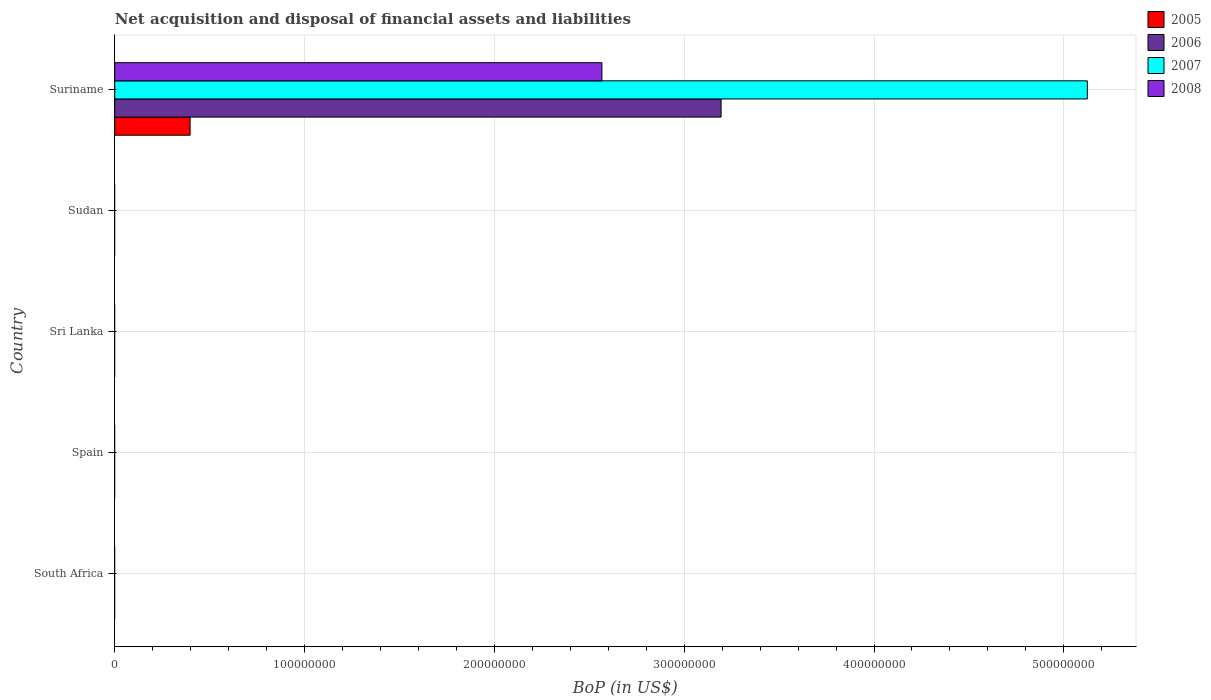How many different coloured bars are there?
Your answer should be compact. 4. How many bars are there on the 2nd tick from the top?
Offer a very short reply. 0. What is the label of the 2nd group of bars from the top?
Provide a short and direct response. Sudan. What is the Balance of Payments in 2006 in South Africa?
Offer a terse response. 0. Across all countries, what is the maximum Balance of Payments in 2006?
Give a very brief answer. 3.19e+08. Across all countries, what is the minimum Balance of Payments in 2005?
Ensure brevity in your answer.  0. In which country was the Balance of Payments in 2008 maximum?
Give a very brief answer. Suriname. What is the total Balance of Payments in 2005 in the graph?
Your response must be concise. 3.97e+07. What is the difference between the Balance of Payments in 2007 in Suriname and the Balance of Payments in 2005 in Spain?
Your answer should be compact. 5.12e+08. What is the average Balance of Payments in 2006 per country?
Ensure brevity in your answer.  6.39e+07. What is the difference between the Balance of Payments in 2005 and Balance of Payments in 2008 in Suriname?
Your answer should be very brief. -2.17e+08. What is the difference between the highest and the lowest Balance of Payments in 2005?
Your response must be concise. 3.97e+07. Is it the case that in every country, the sum of the Balance of Payments in 2005 and Balance of Payments in 2008 is greater than the Balance of Payments in 2007?
Your answer should be compact. No. How many bars are there?
Offer a very short reply. 4. Are the values on the major ticks of X-axis written in scientific E-notation?
Your response must be concise. No. Does the graph contain any zero values?
Make the answer very short. Yes. Does the graph contain grids?
Ensure brevity in your answer.  Yes. Where does the legend appear in the graph?
Provide a succinct answer. Top right. How many legend labels are there?
Offer a terse response. 4. How are the legend labels stacked?
Your response must be concise. Vertical. What is the title of the graph?
Keep it short and to the point. Net acquisition and disposal of financial assets and liabilities. Does "1970" appear as one of the legend labels in the graph?
Make the answer very short. No. What is the label or title of the X-axis?
Offer a very short reply. BoP (in US$). What is the label or title of the Y-axis?
Provide a succinct answer. Country. What is the BoP (in US$) in 2005 in South Africa?
Your answer should be compact. 0. What is the BoP (in US$) of 2006 in South Africa?
Give a very brief answer. 0. What is the BoP (in US$) of 2007 in South Africa?
Your answer should be very brief. 0. What is the BoP (in US$) of 2008 in South Africa?
Keep it short and to the point. 0. What is the BoP (in US$) in 2007 in Spain?
Ensure brevity in your answer.  0. What is the BoP (in US$) of 2008 in Spain?
Your answer should be very brief. 0. What is the BoP (in US$) in 2005 in Sri Lanka?
Make the answer very short. 0. What is the BoP (in US$) of 2006 in Sri Lanka?
Keep it short and to the point. 0. What is the BoP (in US$) of 2007 in Sri Lanka?
Your response must be concise. 0. What is the BoP (in US$) in 2008 in Sri Lanka?
Provide a succinct answer. 0. What is the BoP (in US$) of 2006 in Sudan?
Provide a succinct answer. 0. What is the BoP (in US$) of 2007 in Sudan?
Give a very brief answer. 0. What is the BoP (in US$) of 2005 in Suriname?
Provide a succinct answer. 3.97e+07. What is the BoP (in US$) of 2006 in Suriname?
Offer a very short reply. 3.19e+08. What is the BoP (in US$) in 2007 in Suriname?
Provide a short and direct response. 5.12e+08. What is the BoP (in US$) of 2008 in Suriname?
Provide a short and direct response. 2.57e+08. Across all countries, what is the maximum BoP (in US$) in 2005?
Make the answer very short. 3.97e+07. Across all countries, what is the maximum BoP (in US$) in 2006?
Your response must be concise. 3.19e+08. Across all countries, what is the maximum BoP (in US$) in 2007?
Make the answer very short. 5.12e+08. Across all countries, what is the maximum BoP (in US$) of 2008?
Offer a terse response. 2.57e+08. Across all countries, what is the minimum BoP (in US$) in 2005?
Your response must be concise. 0. What is the total BoP (in US$) in 2005 in the graph?
Provide a succinct answer. 3.97e+07. What is the total BoP (in US$) in 2006 in the graph?
Provide a succinct answer. 3.19e+08. What is the total BoP (in US$) of 2007 in the graph?
Make the answer very short. 5.12e+08. What is the total BoP (in US$) in 2008 in the graph?
Provide a short and direct response. 2.57e+08. What is the average BoP (in US$) of 2005 per country?
Give a very brief answer. 7.94e+06. What is the average BoP (in US$) in 2006 per country?
Your answer should be compact. 6.39e+07. What is the average BoP (in US$) of 2007 per country?
Ensure brevity in your answer.  1.02e+08. What is the average BoP (in US$) of 2008 per country?
Your answer should be compact. 5.13e+07. What is the difference between the BoP (in US$) of 2005 and BoP (in US$) of 2006 in Suriname?
Offer a very short reply. -2.80e+08. What is the difference between the BoP (in US$) of 2005 and BoP (in US$) of 2007 in Suriname?
Your answer should be very brief. -4.73e+08. What is the difference between the BoP (in US$) in 2005 and BoP (in US$) in 2008 in Suriname?
Offer a very short reply. -2.17e+08. What is the difference between the BoP (in US$) in 2006 and BoP (in US$) in 2007 in Suriname?
Keep it short and to the point. -1.93e+08. What is the difference between the BoP (in US$) in 2006 and BoP (in US$) in 2008 in Suriname?
Keep it short and to the point. 6.28e+07. What is the difference between the BoP (in US$) of 2007 and BoP (in US$) of 2008 in Suriname?
Offer a very short reply. 2.56e+08. What is the difference between the highest and the lowest BoP (in US$) in 2005?
Your response must be concise. 3.97e+07. What is the difference between the highest and the lowest BoP (in US$) in 2006?
Provide a succinct answer. 3.19e+08. What is the difference between the highest and the lowest BoP (in US$) in 2007?
Make the answer very short. 5.12e+08. What is the difference between the highest and the lowest BoP (in US$) of 2008?
Your answer should be very brief. 2.57e+08. 